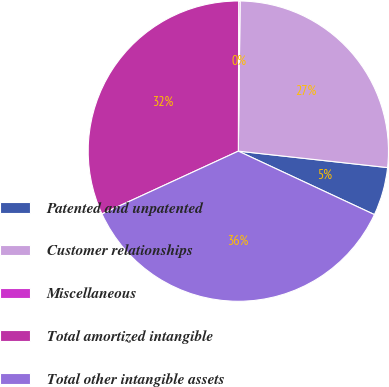Convert chart to OTSL. <chart><loc_0><loc_0><loc_500><loc_500><pie_chart><fcel>Patented and unpatented<fcel>Customer relationships<fcel>Miscellaneous<fcel>Total amortized intangible<fcel>Total other intangible assets<nl><fcel>5.2%<fcel>26.56%<fcel>0.15%<fcel>31.91%<fcel>36.19%<nl></chart> 